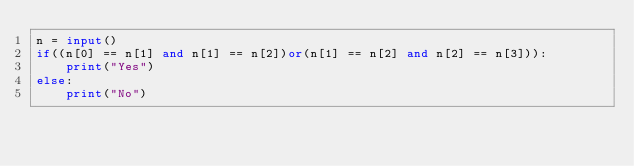<code> <loc_0><loc_0><loc_500><loc_500><_Python_>n = input()
if((n[0] == n[1] and n[1] == n[2])or(n[1] == n[2] and n[2] == n[3])):
    print("Yes")
else:
    print("No")
</code> 